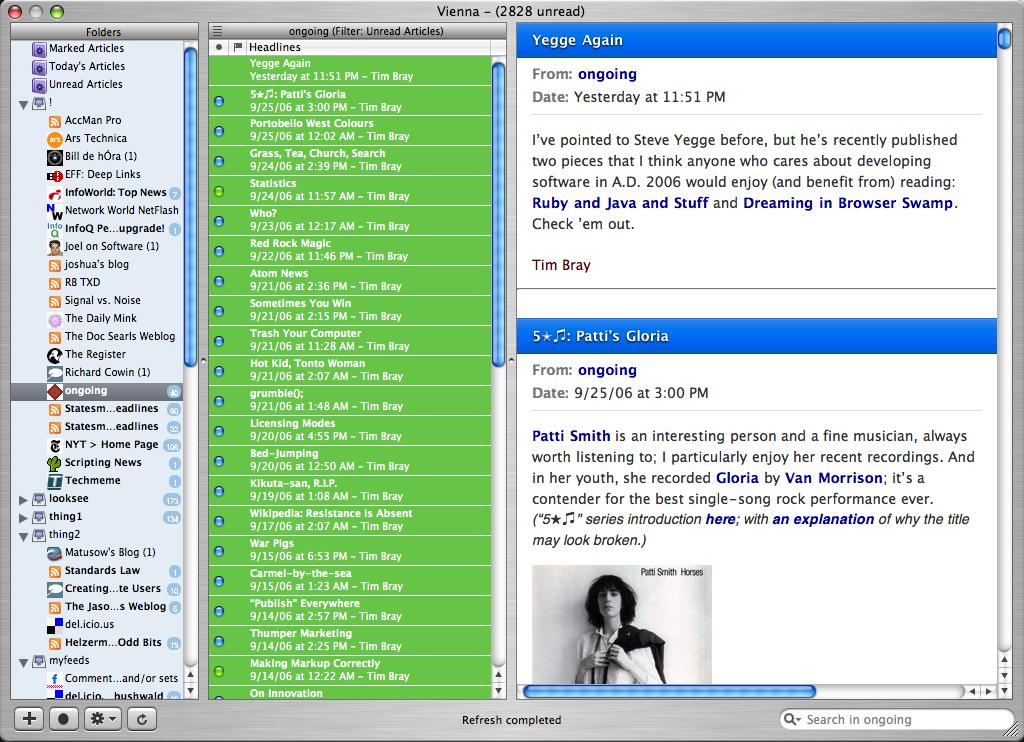What is the main object in the image? There is a computer screen in the image. What can be seen on the computer screen? There is content and images on the computer screen. What type of glove is being used to interact with the computer screen in the image? There is no glove present in the image; the computer screen is being viewed directly. 